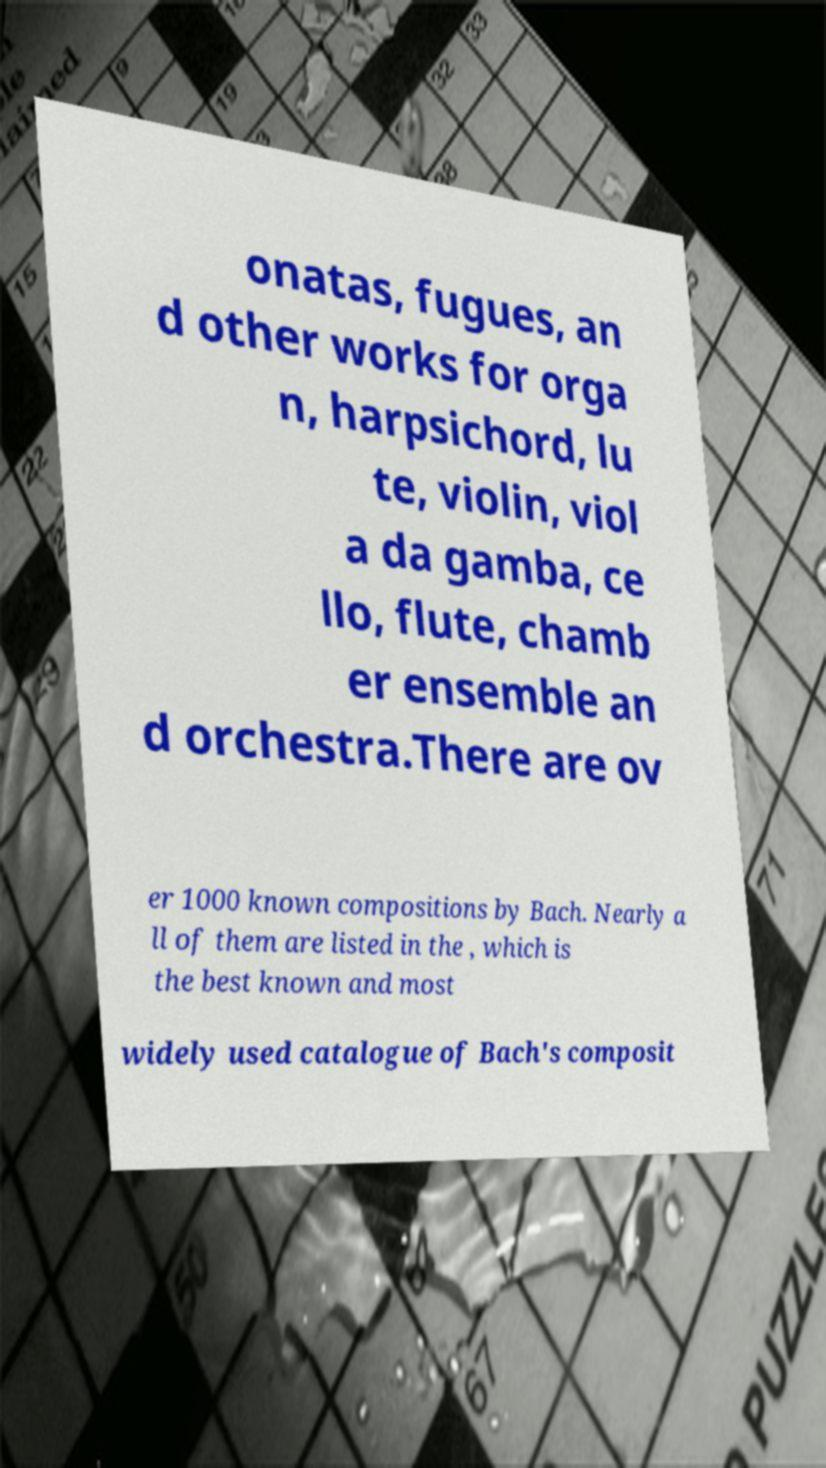Please read and relay the text visible in this image. What does it say? onatas, fugues, an d other works for orga n, harpsichord, lu te, violin, viol a da gamba, ce llo, flute, chamb er ensemble an d orchestra.There are ov er 1000 known compositions by Bach. Nearly a ll of them are listed in the , which is the best known and most widely used catalogue of Bach's composit 